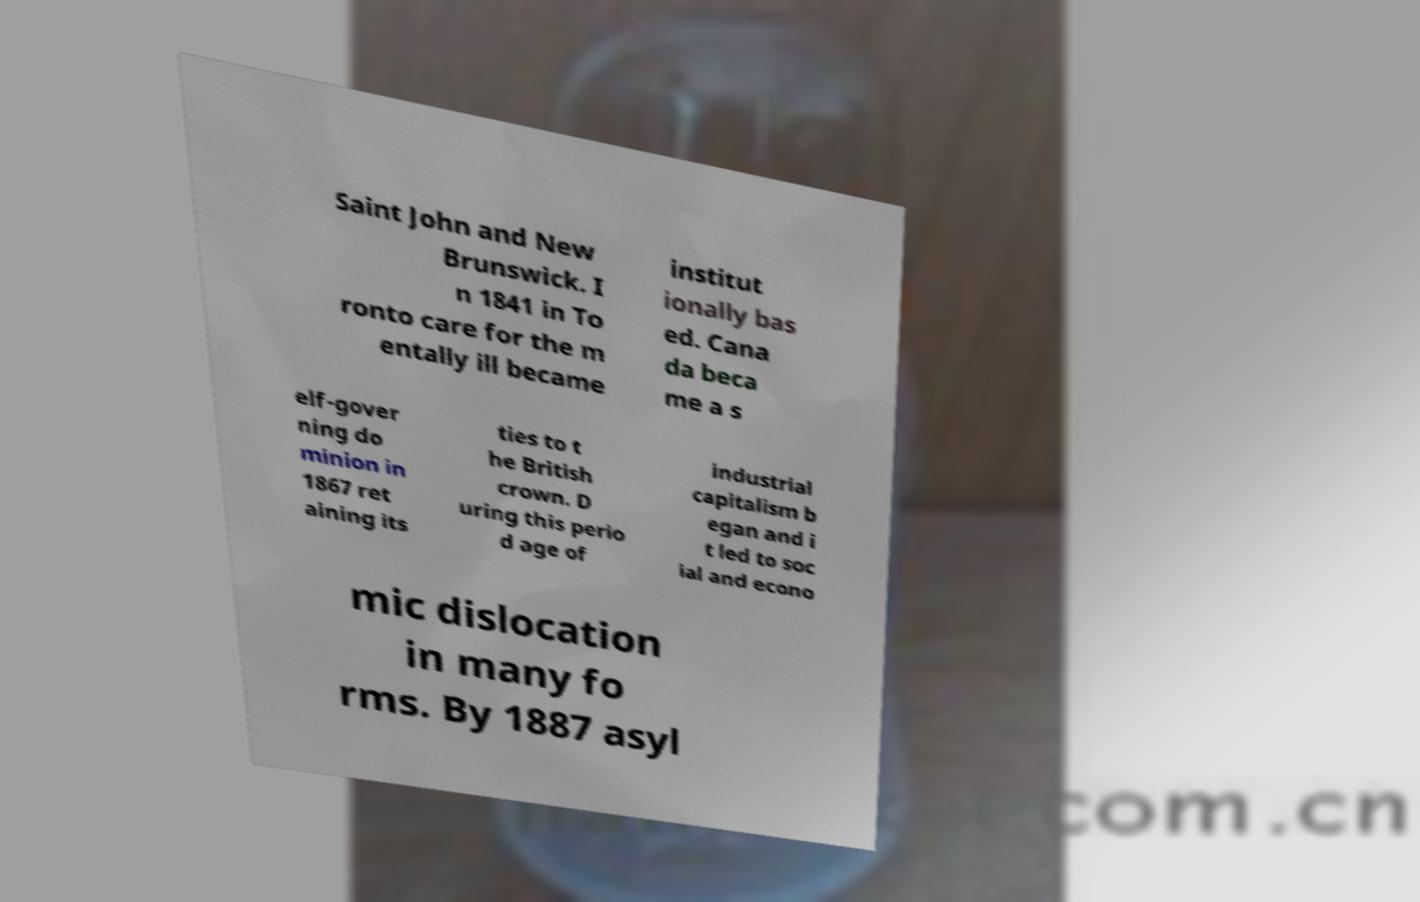Could you assist in decoding the text presented in this image and type it out clearly? Saint John and New Brunswick. I n 1841 in To ronto care for the m entally ill became institut ionally bas ed. Cana da beca me a s elf-gover ning do minion in 1867 ret aining its ties to t he British crown. D uring this perio d age of industrial capitalism b egan and i t led to soc ial and econo mic dislocation in many fo rms. By 1887 asyl 